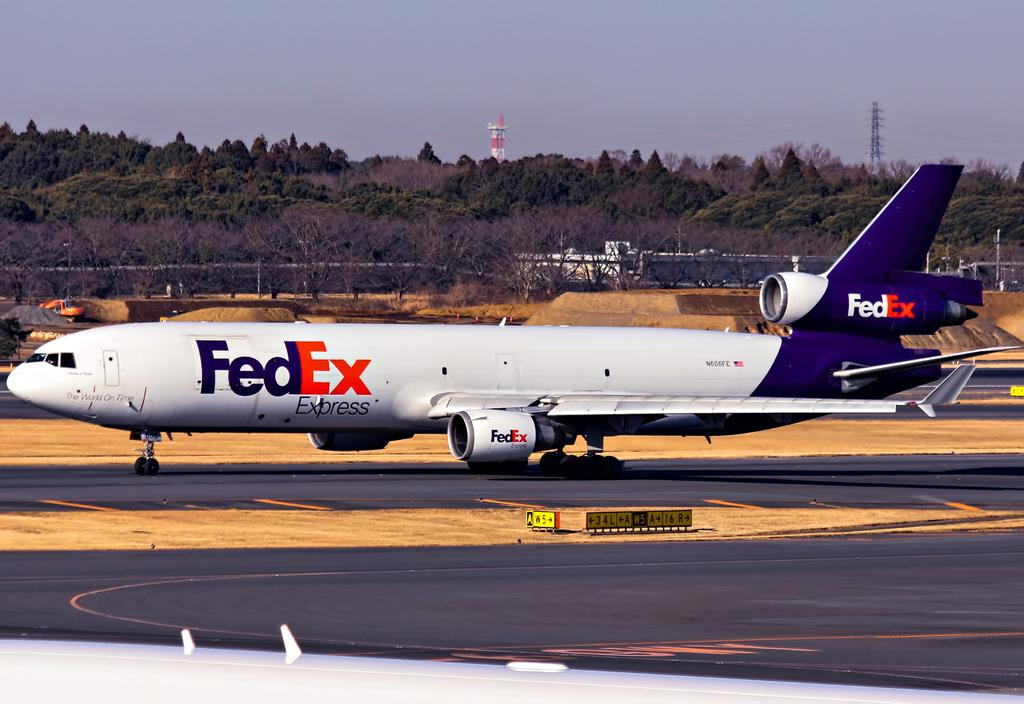What is the main subject of the image? The main subject of the image is an airplane. Where is the airplane located in the image? The airplane is on the land in the image. What can be seen behind the airplane? There are trees behind the airplane. What other structures are visible in the background of the image? There are two towers in the background of the image. What arithmetic problem is being solved on the airplane's wing in the image? There is no arithmetic problem visible on the airplane's wing in the image. What type of room is located inside the airplane in the image? There is no room visible inside the airplane in the image, as it is on the land and not in flight. 